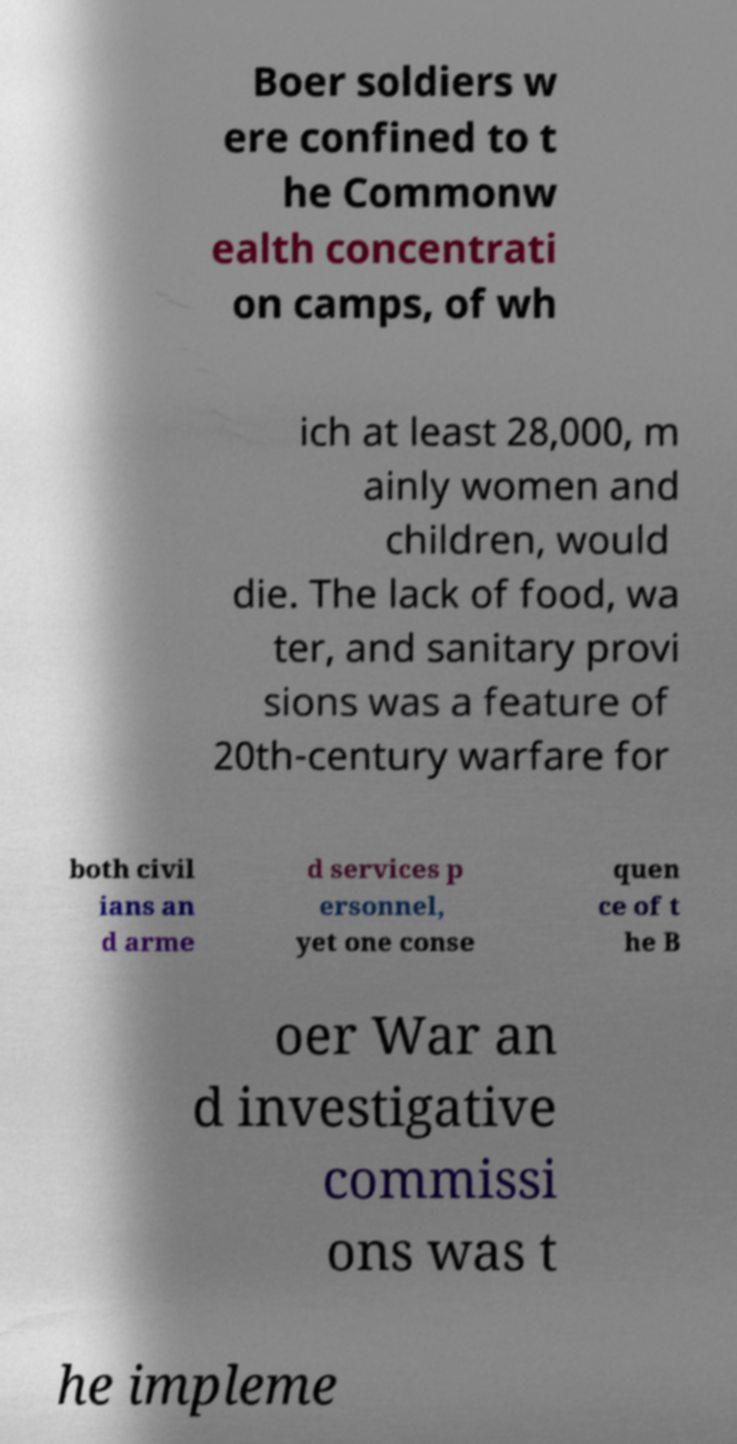For documentation purposes, I need the text within this image transcribed. Could you provide that? Boer soldiers w ere confined to t he Commonw ealth concentrati on camps, of wh ich at least 28,000, m ainly women and children, would die. The lack of food, wa ter, and sanitary provi sions was a feature of 20th-century warfare for both civil ians an d arme d services p ersonnel, yet one conse quen ce of t he B oer War an d investigative commissi ons was t he impleme 